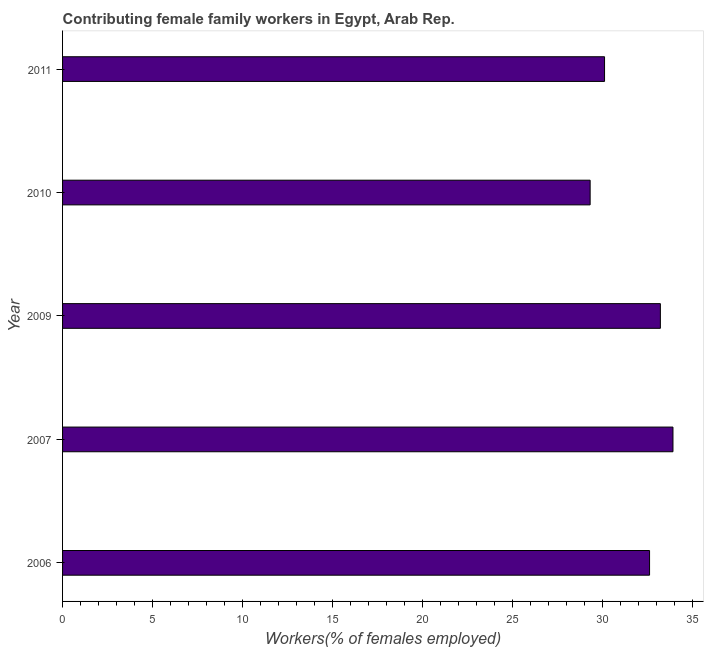Does the graph contain any zero values?
Ensure brevity in your answer.  No. What is the title of the graph?
Provide a succinct answer. Contributing female family workers in Egypt, Arab Rep. What is the label or title of the X-axis?
Offer a terse response. Workers(% of females employed). What is the label or title of the Y-axis?
Your answer should be compact. Year. What is the contributing female family workers in 2007?
Your answer should be very brief. 33.9. Across all years, what is the maximum contributing female family workers?
Provide a short and direct response. 33.9. Across all years, what is the minimum contributing female family workers?
Make the answer very short. 29.3. What is the sum of the contributing female family workers?
Offer a terse response. 159.1. What is the difference between the contributing female family workers in 2006 and 2009?
Your response must be concise. -0.6. What is the average contributing female family workers per year?
Provide a short and direct response. 31.82. What is the median contributing female family workers?
Your answer should be very brief. 32.6. In how many years, is the contributing female family workers greater than 28 %?
Ensure brevity in your answer.  5. What is the ratio of the contributing female family workers in 2006 to that in 2010?
Ensure brevity in your answer.  1.11. Is the contributing female family workers in 2007 less than that in 2011?
Provide a short and direct response. No. Is the difference between the contributing female family workers in 2006 and 2007 greater than the difference between any two years?
Make the answer very short. No. What is the difference between the highest and the second highest contributing female family workers?
Keep it short and to the point. 0.7. What is the difference between the highest and the lowest contributing female family workers?
Keep it short and to the point. 4.6. In how many years, is the contributing female family workers greater than the average contributing female family workers taken over all years?
Provide a short and direct response. 3. Are all the bars in the graph horizontal?
Make the answer very short. Yes. What is the difference between two consecutive major ticks on the X-axis?
Provide a succinct answer. 5. Are the values on the major ticks of X-axis written in scientific E-notation?
Offer a very short reply. No. What is the Workers(% of females employed) in 2006?
Make the answer very short. 32.6. What is the Workers(% of females employed) in 2007?
Give a very brief answer. 33.9. What is the Workers(% of females employed) in 2009?
Provide a succinct answer. 33.2. What is the Workers(% of females employed) of 2010?
Ensure brevity in your answer.  29.3. What is the Workers(% of females employed) in 2011?
Your answer should be very brief. 30.1. What is the difference between the Workers(% of females employed) in 2007 and 2010?
Your response must be concise. 4.6. What is the difference between the Workers(% of females employed) in 2009 and 2010?
Make the answer very short. 3.9. What is the ratio of the Workers(% of females employed) in 2006 to that in 2009?
Your answer should be very brief. 0.98. What is the ratio of the Workers(% of females employed) in 2006 to that in 2010?
Your answer should be very brief. 1.11. What is the ratio of the Workers(% of females employed) in 2006 to that in 2011?
Your answer should be compact. 1.08. What is the ratio of the Workers(% of females employed) in 2007 to that in 2010?
Your response must be concise. 1.16. What is the ratio of the Workers(% of females employed) in 2007 to that in 2011?
Provide a succinct answer. 1.13. What is the ratio of the Workers(% of females employed) in 2009 to that in 2010?
Your response must be concise. 1.13. What is the ratio of the Workers(% of females employed) in 2009 to that in 2011?
Your answer should be very brief. 1.1. What is the ratio of the Workers(% of females employed) in 2010 to that in 2011?
Your answer should be compact. 0.97. 